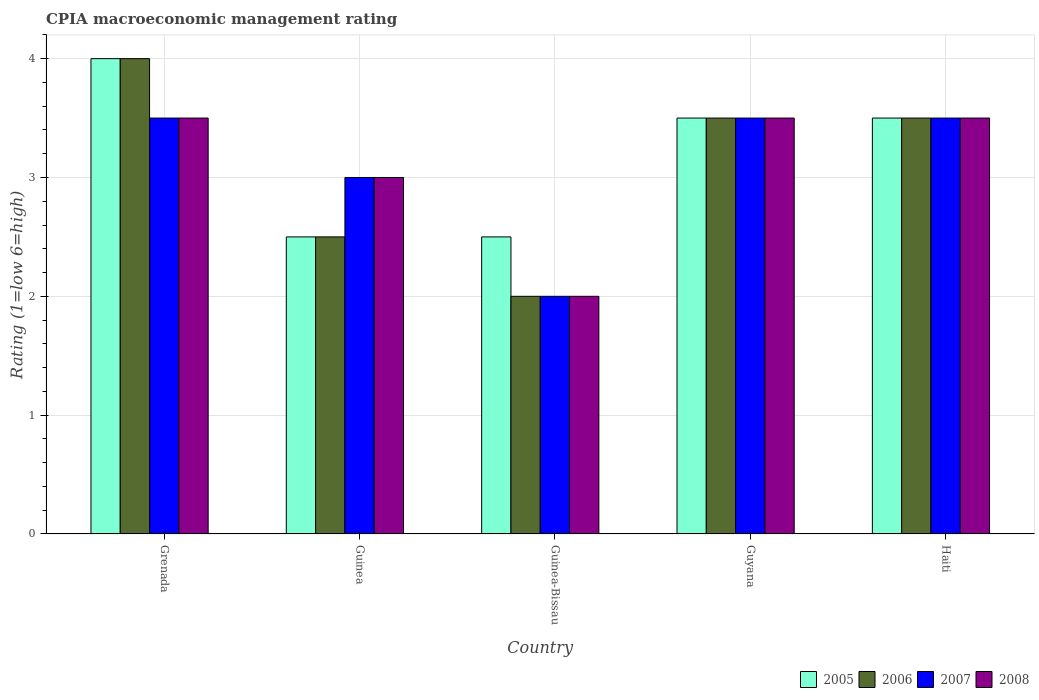How many different coloured bars are there?
Provide a short and direct response. 4. Are the number of bars on each tick of the X-axis equal?
Keep it short and to the point. Yes. How many bars are there on the 3rd tick from the left?
Your answer should be compact. 4. What is the label of the 2nd group of bars from the left?
Give a very brief answer. Guinea. What is the CPIA rating in 2007 in Haiti?
Your answer should be compact. 3.5. Across all countries, what is the maximum CPIA rating in 2008?
Offer a terse response. 3.5. In which country was the CPIA rating in 2008 maximum?
Your answer should be very brief. Grenada. In which country was the CPIA rating in 2006 minimum?
Offer a terse response. Guinea-Bissau. What is the total CPIA rating in 2006 in the graph?
Provide a short and direct response. 15.5. What is the difference between the CPIA rating in 2006 in Grenada and that in Guyana?
Provide a short and direct response. 0.5. What is the difference between the highest and the second highest CPIA rating in 2005?
Offer a terse response. -0.5. What is the difference between the highest and the lowest CPIA rating in 2008?
Give a very brief answer. 1.5. In how many countries, is the CPIA rating in 2005 greater than the average CPIA rating in 2005 taken over all countries?
Provide a short and direct response. 3. Is the sum of the CPIA rating in 2008 in Guinea and Haiti greater than the maximum CPIA rating in 2007 across all countries?
Provide a succinct answer. Yes. Is it the case that in every country, the sum of the CPIA rating in 2008 and CPIA rating in 2007 is greater than the sum of CPIA rating in 2005 and CPIA rating in 2006?
Offer a terse response. No. Is it the case that in every country, the sum of the CPIA rating in 2008 and CPIA rating in 2007 is greater than the CPIA rating in 2005?
Give a very brief answer. Yes. How many bars are there?
Offer a terse response. 20. Are all the bars in the graph horizontal?
Your answer should be very brief. No. How many countries are there in the graph?
Offer a very short reply. 5. Does the graph contain any zero values?
Your answer should be very brief. No. Where does the legend appear in the graph?
Ensure brevity in your answer.  Bottom right. How are the legend labels stacked?
Give a very brief answer. Horizontal. What is the title of the graph?
Give a very brief answer. CPIA macroeconomic management rating. Does "1996" appear as one of the legend labels in the graph?
Your answer should be compact. No. What is the Rating (1=low 6=high) in 2005 in Grenada?
Your answer should be compact. 4. What is the Rating (1=low 6=high) of 2007 in Grenada?
Keep it short and to the point. 3.5. What is the Rating (1=low 6=high) of 2008 in Guinea?
Your response must be concise. 3. What is the Rating (1=low 6=high) of 2005 in Guinea-Bissau?
Ensure brevity in your answer.  2.5. What is the Rating (1=low 6=high) in 2008 in Guinea-Bissau?
Provide a succinct answer. 2. What is the Rating (1=low 6=high) of 2005 in Guyana?
Provide a succinct answer. 3.5. What is the Rating (1=low 6=high) of 2006 in Haiti?
Your response must be concise. 3.5. What is the Rating (1=low 6=high) of 2007 in Haiti?
Give a very brief answer. 3.5. Across all countries, what is the maximum Rating (1=low 6=high) in 2005?
Give a very brief answer. 4. Across all countries, what is the maximum Rating (1=low 6=high) in 2007?
Give a very brief answer. 3.5. Across all countries, what is the maximum Rating (1=low 6=high) in 2008?
Your answer should be very brief. 3.5. What is the total Rating (1=low 6=high) in 2006 in the graph?
Your answer should be very brief. 15.5. What is the total Rating (1=low 6=high) in 2007 in the graph?
Offer a very short reply. 15.5. What is the total Rating (1=low 6=high) in 2008 in the graph?
Provide a succinct answer. 15.5. What is the difference between the Rating (1=low 6=high) of 2005 in Grenada and that in Guinea?
Your answer should be compact. 1.5. What is the difference between the Rating (1=low 6=high) of 2005 in Grenada and that in Guinea-Bissau?
Offer a terse response. 1.5. What is the difference between the Rating (1=low 6=high) in 2008 in Grenada and that in Guinea-Bissau?
Ensure brevity in your answer.  1.5. What is the difference between the Rating (1=low 6=high) of 2008 in Grenada and that in Guyana?
Your answer should be very brief. 0. What is the difference between the Rating (1=low 6=high) of 2005 in Grenada and that in Haiti?
Your response must be concise. 0.5. What is the difference between the Rating (1=low 6=high) of 2006 in Grenada and that in Haiti?
Give a very brief answer. 0.5. What is the difference between the Rating (1=low 6=high) of 2007 in Grenada and that in Haiti?
Provide a short and direct response. 0. What is the difference between the Rating (1=low 6=high) of 2007 in Guinea and that in Guinea-Bissau?
Provide a succinct answer. 1. What is the difference between the Rating (1=low 6=high) in 2005 in Guinea and that in Guyana?
Offer a terse response. -1. What is the difference between the Rating (1=low 6=high) of 2008 in Guinea and that in Guyana?
Make the answer very short. -0.5. What is the difference between the Rating (1=low 6=high) in 2007 in Guinea and that in Haiti?
Your answer should be very brief. -0.5. What is the difference between the Rating (1=low 6=high) in 2005 in Guinea-Bissau and that in Guyana?
Make the answer very short. -1. What is the difference between the Rating (1=low 6=high) of 2006 in Guinea-Bissau and that in Guyana?
Provide a short and direct response. -1.5. What is the difference between the Rating (1=low 6=high) in 2007 in Guinea-Bissau and that in Guyana?
Provide a succinct answer. -1.5. What is the difference between the Rating (1=low 6=high) in 2005 in Guinea-Bissau and that in Haiti?
Your answer should be very brief. -1. What is the difference between the Rating (1=low 6=high) in 2007 in Guinea-Bissau and that in Haiti?
Your answer should be compact. -1.5. What is the difference between the Rating (1=low 6=high) in 2005 in Guyana and that in Haiti?
Your response must be concise. 0. What is the difference between the Rating (1=low 6=high) of 2007 in Guyana and that in Haiti?
Your answer should be very brief. 0. What is the difference between the Rating (1=low 6=high) in 2005 in Grenada and the Rating (1=low 6=high) in 2007 in Guinea?
Your answer should be compact. 1. What is the difference between the Rating (1=low 6=high) in 2007 in Grenada and the Rating (1=low 6=high) in 2008 in Guinea?
Offer a terse response. 0.5. What is the difference between the Rating (1=low 6=high) of 2005 in Grenada and the Rating (1=low 6=high) of 2007 in Guinea-Bissau?
Your answer should be very brief. 2. What is the difference between the Rating (1=low 6=high) in 2005 in Grenada and the Rating (1=low 6=high) in 2008 in Guinea-Bissau?
Your answer should be very brief. 2. What is the difference between the Rating (1=low 6=high) of 2006 in Grenada and the Rating (1=low 6=high) of 2008 in Guinea-Bissau?
Offer a very short reply. 2. What is the difference between the Rating (1=low 6=high) in 2005 in Grenada and the Rating (1=low 6=high) in 2008 in Guyana?
Make the answer very short. 0.5. What is the difference between the Rating (1=low 6=high) of 2006 in Grenada and the Rating (1=low 6=high) of 2008 in Guyana?
Ensure brevity in your answer.  0.5. What is the difference between the Rating (1=low 6=high) of 2007 in Grenada and the Rating (1=low 6=high) of 2008 in Guyana?
Offer a terse response. 0. What is the difference between the Rating (1=low 6=high) in 2005 in Grenada and the Rating (1=low 6=high) in 2006 in Haiti?
Keep it short and to the point. 0.5. What is the difference between the Rating (1=low 6=high) of 2006 in Grenada and the Rating (1=low 6=high) of 2007 in Haiti?
Offer a terse response. 0.5. What is the difference between the Rating (1=low 6=high) in 2006 in Grenada and the Rating (1=low 6=high) in 2008 in Haiti?
Your answer should be very brief. 0.5. What is the difference between the Rating (1=low 6=high) of 2005 in Guinea and the Rating (1=low 6=high) of 2006 in Guinea-Bissau?
Keep it short and to the point. 0.5. What is the difference between the Rating (1=low 6=high) of 2005 in Guinea and the Rating (1=low 6=high) of 2007 in Guinea-Bissau?
Provide a short and direct response. 0.5. What is the difference between the Rating (1=low 6=high) of 2006 in Guinea and the Rating (1=low 6=high) of 2007 in Guinea-Bissau?
Make the answer very short. 0.5. What is the difference between the Rating (1=low 6=high) in 2007 in Guinea and the Rating (1=low 6=high) in 2008 in Guinea-Bissau?
Your answer should be compact. 1. What is the difference between the Rating (1=low 6=high) of 2005 in Guinea and the Rating (1=low 6=high) of 2006 in Guyana?
Your answer should be compact. -1. What is the difference between the Rating (1=low 6=high) in 2005 in Guinea and the Rating (1=low 6=high) in 2008 in Guyana?
Offer a very short reply. -1. What is the difference between the Rating (1=low 6=high) of 2007 in Guinea and the Rating (1=low 6=high) of 2008 in Guyana?
Provide a short and direct response. -0.5. What is the difference between the Rating (1=low 6=high) in 2005 in Guinea and the Rating (1=low 6=high) in 2006 in Haiti?
Offer a very short reply. -1. What is the difference between the Rating (1=low 6=high) in 2006 in Guinea and the Rating (1=low 6=high) in 2008 in Haiti?
Keep it short and to the point. -1. What is the difference between the Rating (1=low 6=high) of 2007 in Guinea and the Rating (1=low 6=high) of 2008 in Haiti?
Offer a terse response. -0.5. What is the difference between the Rating (1=low 6=high) in 2005 in Guinea-Bissau and the Rating (1=low 6=high) in 2006 in Guyana?
Offer a very short reply. -1. What is the difference between the Rating (1=low 6=high) in 2005 in Guinea-Bissau and the Rating (1=low 6=high) in 2008 in Guyana?
Your answer should be compact. -1. What is the difference between the Rating (1=low 6=high) of 2006 in Guinea-Bissau and the Rating (1=low 6=high) of 2007 in Guyana?
Offer a terse response. -1.5. What is the difference between the Rating (1=low 6=high) of 2007 in Guinea-Bissau and the Rating (1=low 6=high) of 2008 in Guyana?
Your answer should be very brief. -1.5. What is the difference between the Rating (1=low 6=high) of 2007 in Guinea-Bissau and the Rating (1=low 6=high) of 2008 in Haiti?
Ensure brevity in your answer.  -1.5. What is the difference between the Rating (1=low 6=high) of 2005 in Guyana and the Rating (1=low 6=high) of 2006 in Haiti?
Provide a short and direct response. 0. What is the difference between the Rating (1=low 6=high) in 2005 in Guyana and the Rating (1=low 6=high) in 2008 in Haiti?
Ensure brevity in your answer.  0. What is the difference between the Rating (1=low 6=high) in 2006 in Guyana and the Rating (1=low 6=high) in 2007 in Haiti?
Your answer should be compact. 0. What is the difference between the Rating (1=low 6=high) of 2006 in Guyana and the Rating (1=low 6=high) of 2008 in Haiti?
Your answer should be very brief. 0. What is the average Rating (1=low 6=high) in 2006 per country?
Offer a very short reply. 3.1. What is the average Rating (1=low 6=high) of 2008 per country?
Offer a very short reply. 3.1. What is the difference between the Rating (1=low 6=high) in 2005 and Rating (1=low 6=high) in 2006 in Grenada?
Your answer should be compact. 0. What is the difference between the Rating (1=low 6=high) of 2005 and Rating (1=low 6=high) of 2008 in Grenada?
Provide a short and direct response. 0.5. What is the difference between the Rating (1=low 6=high) in 2006 and Rating (1=low 6=high) in 2007 in Grenada?
Ensure brevity in your answer.  0.5. What is the difference between the Rating (1=low 6=high) of 2007 and Rating (1=low 6=high) of 2008 in Grenada?
Provide a succinct answer. 0. What is the difference between the Rating (1=low 6=high) in 2005 and Rating (1=low 6=high) in 2006 in Guinea?
Provide a short and direct response. 0. What is the difference between the Rating (1=low 6=high) in 2005 and Rating (1=low 6=high) in 2007 in Guinea?
Offer a terse response. -0.5. What is the difference between the Rating (1=low 6=high) of 2005 and Rating (1=low 6=high) of 2007 in Guinea-Bissau?
Offer a terse response. 0.5. What is the difference between the Rating (1=low 6=high) in 2005 and Rating (1=low 6=high) in 2008 in Guinea-Bissau?
Ensure brevity in your answer.  0.5. What is the difference between the Rating (1=low 6=high) of 2006 and Rating (1=low 6=high) of 2007 in Guinea-Bissau?
Provide a succinct answer. 0. What is the difference between the Rating (1=low 6=high) of 2006 and Rating (1=low 6=high) of 2008 in Guinea-Bissau?
Provide a succinct answer. 0. What is the difference between the Rating (1=low 6=high) in 2007 and Rating (1=low 6=high) in 2008 in Guinea-Bissau?
Give a very brief answer. 0. What is the difference between the Rating (1=low 6=high) of 2005 and Rating (1=low 6=high) of 2006 in Guyana?
Offer a very short reply. 0. What is the difference between the Rating (1=low 6=high) in 2005 and Rating (1=low 6=high) in 2008 in Guyana?
Provide a short and direct response. 0. What is the difference between the Rating (1=low 6=high) in 2006 and Rating (1=low 6=high) in 2007 in Guyana?
Provide a short and direct response. 0. What is the difference between the Rating (1=low 6=high) of 2006 and Rating (1=low 6=high) of 2008 in Guyana?
Provide a succinct answer. 0. What is the difference between the Rating (1=low 6=high) in 2005 and Rating (1=low 6=high) in 2006 in Haiti?
Your answer should be very brief. 0. What is the difference between the Rating (1=low 6=high) of 2006 and Rating (1=low 6=high) of 2007 in Haiti?
Offer a terse response. 0. What is the difference between the Rating (1=low 6=high) of 2006 and Rating (1=low 6=high) of 2008 in Haiti?
Give a very brief answer. 0. What is the ratio of the Rating (1=low 6=high) of 2006 in Grenada to that in Guinea?
Ensure brevity in your answer.  1.6. What is the ratio of the Rating (1=low 6=high) in 2008 in Grenada to that in Guinea?
Ensure brevity in your answer.  1.17. What is the ratio of the Rating (1=low 6=high) of 2005 in Grenada to that in Guinea-Bissau?
Keep it short and to the point. 1.6. What is the ratio of the Rating (1=low 6=high) in 2007 in Grenada to that in Guinea-Bissau?
Your answer should be compact. 1.75. What is the ratio of the Rating (1=low 6=high) of 2008 in Grenada to that in Guinea-Bissau?
Provide a succinct answer. 1.75. What is the ratio of the Rating (1=low 6=high) of 2005 in Grenada to that in Guyana?
Provide a succinct answer. 1.14. What is the ratio of the Rating (1=low 6=high) in 2006 in Grenada to that in Guyana?
Give a very brief answer. 1.14. What is the ratio of the Rating (1=low 6=high) of 2007 in Grenada to that in Guyana?
Keep it short and to the point. 1. What is the ratio of the Rating (1=low 6=high) in 2005 in Grenada to that in Haiti?
Your answer should be compact. 1.14. What is the ratio of the Rating (1=low 6=high) in 2006 in Grenada to that in Haiti?
Make the answer very short. 1.14. What is the ratio of the Rating (1=low 6=high) of 2007 in Grenada to that in Haiti?
Your response must be concise. 1. What is the ratio of the Rating (1=low 6=high) of 2006 in Guinea to that in Guinea-Bissau?
Ensure brevity in your answer.  1.25. What is the ratio of the Rating (1=low 6=high) in 2008 in Guinea to that in Guinea-Bissau?
Make the answer very short. 1.5. What is the ratio of the Rating (1=low 6=high) in 2005 in Guinea to that in Guyana?
Make the answer very short. 0.71. What is the ratio of the Rating (1=low 6=high) of 2008 in Guinea to that in Guyana?
Make the answer very short. 0.86. What is the ratio of the Rating (1=low 6=high) of 2005 in Guinea to that in Haiti?
Make the answer very short. 0.71. What is the ratio of the Rating (1=low 6=high) of 2006 in Guinea to that in Haiti?
Provide a succinct answer. 0.71. What is the ratio of the Rating (1=low 6=high) of 2007 in Guinea to that in Haiti?
Ensure brevity in your answer.  0.86. What is the ratio of the Rating (1=low 6=high) of 2008 in Guinea to that in Haiti?
Offer a terse response. 0.86. What is the ratio of the Rating (1=low 6=high) of 2005 in Guinea-Bissau to that in Guyana?
Offer a terse response. 0.71. What is the ratio of the Rating (1=low 6=high) in 2007 in Guinea-Bissau to that in Guyana?
Ensure brevity in your answer.  0.57. What is the ratio of the Rating (1=low 6=high) of 2005 in Guinea-Bissau to that in Haiti?
Provide a succinct answer. 0.71. What is the ratio of the Rating (1=low 6=high) in 2006 in Guinea-Bissau to that in Haiti?
Offer a terse response. 0.57. What is the ratio of the Rating (1=low 6=high) in 2007 in Guinea-Bissau to that in Haiti?
Give a very brief answer. 0.57. What is the ratio of the Rating (1=low 6=high) of 2006 in Guyana to that in Haiti?
Keep it short and to the point. 1. What is the ratio of the Rating (1=low 6=high) in 2008 in Guyana to that in Haiti?
Provide a short and direct response. 1. What is the difference between the highest and the second highest Rating (1=low 6=high) of 2007?
Offer a very short reply. 0. What is the difference between the highest and the second highest Rating (1=low 6=high) of 2008?
Keep it short and to the point. 0. What is the difference between the highest and the lowest Rating (1=low 6=high) in 2006?
Offer a terse response. 2. What is the difference between the highest and the lowest Rating (1=low 6=high) in 2008?
Make the answer very short. 1.5. 